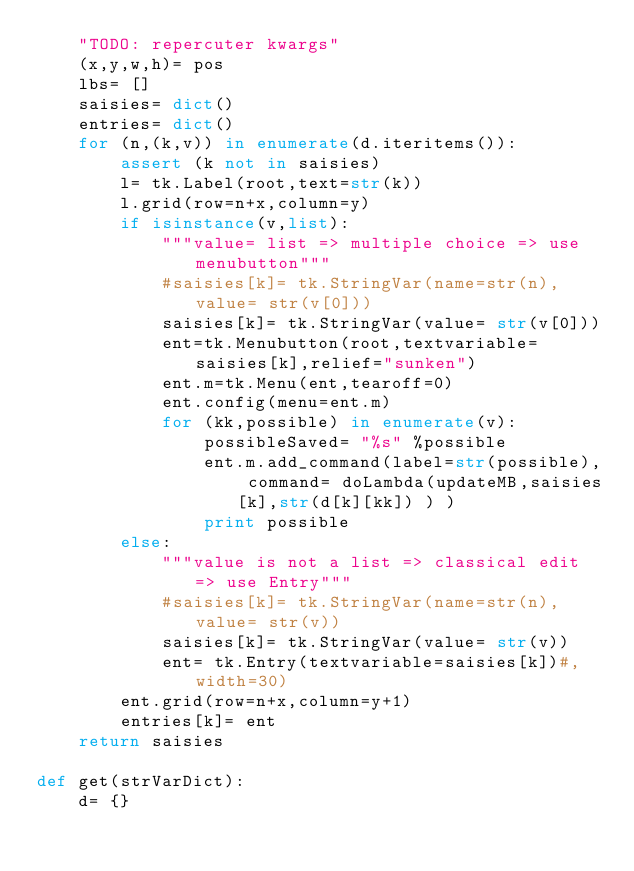Convert code to text. <code><loc_0><loc_0><loc_500><loc_500><_Python_>    "TODO: repercuter kwargs"
    (x,y,w,h)= pos
    lbs= []    
    saisies= dict()    
    entries= dict()
    for (n,(k,v)) in enumerate(d.iteritems()):  
        assert (k not in saisies)        
        l= tk.Label(root,text=str(k))
        l.grid(row=n+x,column=y)               
        if isinstance(v,list):
            """value= list => multiple choice => use menubutton"""            
            #saisies[k]= tk.StringVar(name=str(n),value= str(v[0]))
            saisies[k]= tk.StringVar(value= str(v[0]))            
            ent=tk.Menubutton(root,textvariable=saisies[k],relief="sunken")
            ent.m=tk.Menu(ent,tearoff=0)
            ent.config(menu=ent.m)    
            for (kk,possible) in enumerate(v):             
                possibleSaved= "%s" %possible                 
                ent.m.add_command(label=str(possible), command= doLambda(updateMB,saisies[k],str(d[k][kk]) ) )
                print possible
        else:         
            """value is not a list => classical edit => use Entry""" 
            #saisies[k]= tk.StringVar(name=str(n),value= str(v))
            saisies[k]= tk.StringVar(value= str(v))   
            ent= tk.Entry(textvariable=saisies[k])#,width=30)
        ent.grid(row=n+x,column=y+1)     
        entries[k]= ent
    return saisies

def get(strVarDict):
    d= {}</code> 